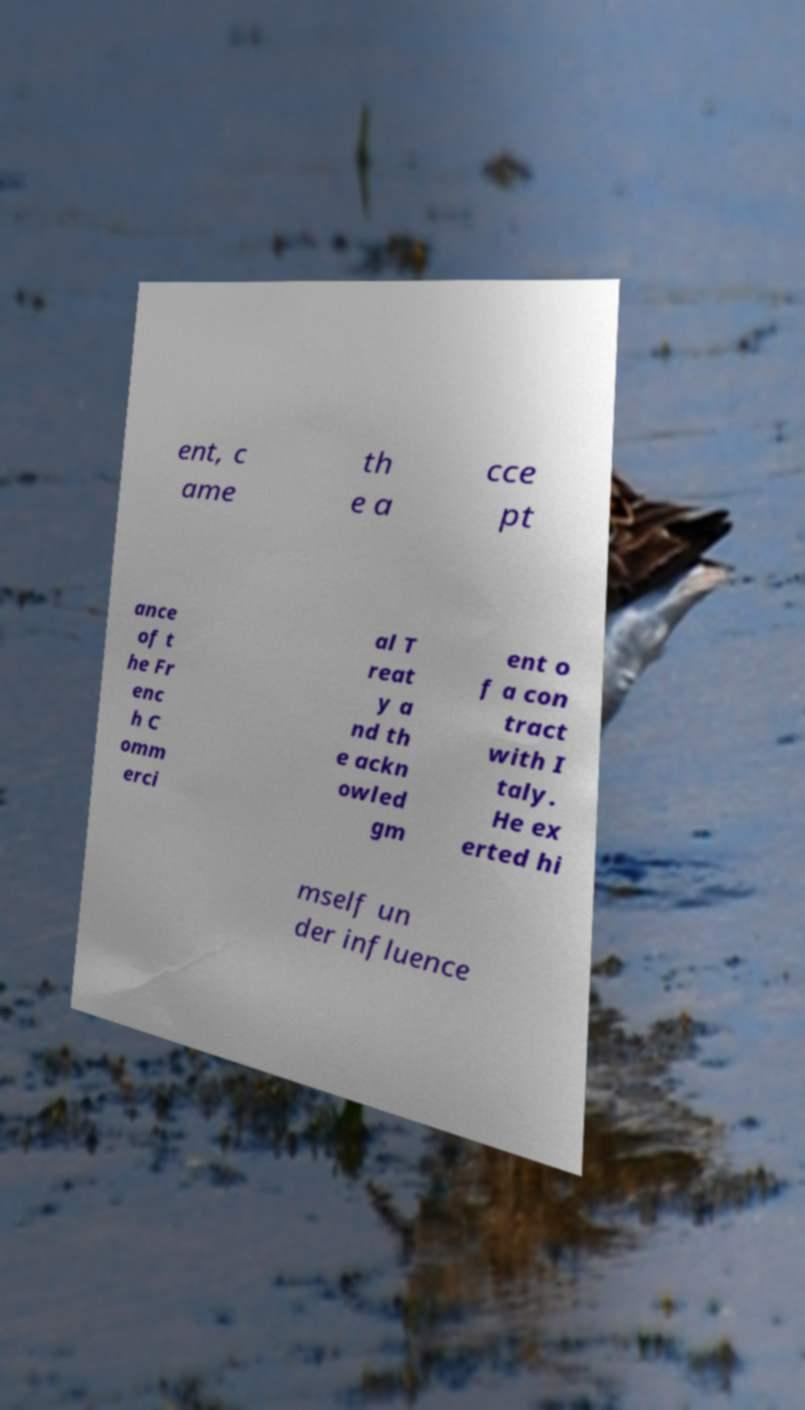There's text embedded in this image that I need extracted. Can you transcribe it verbatim? ent, c ame th e a cce pt ance of t he Fr enc h C omm erci al T reat y a nd th e ackn owled gm ent o f a con tract with I taly. He ex erted hi mself un der influence 